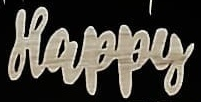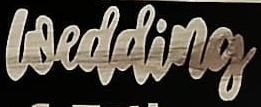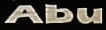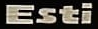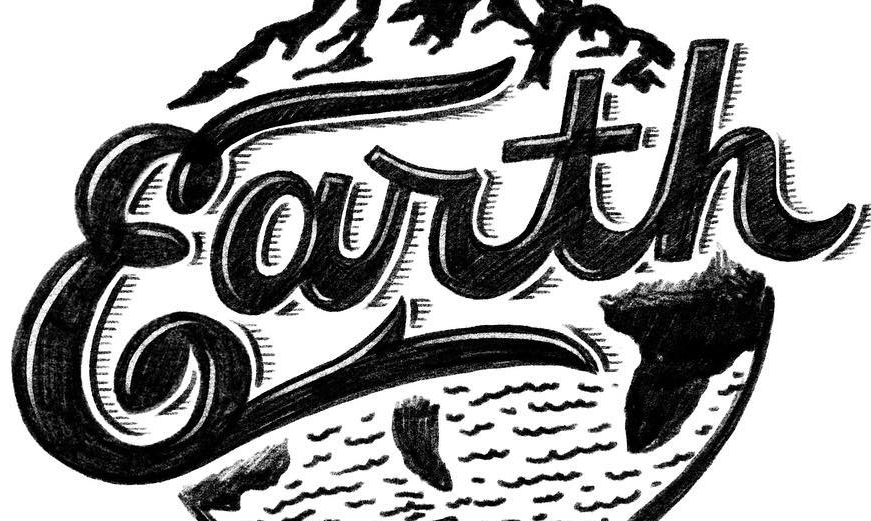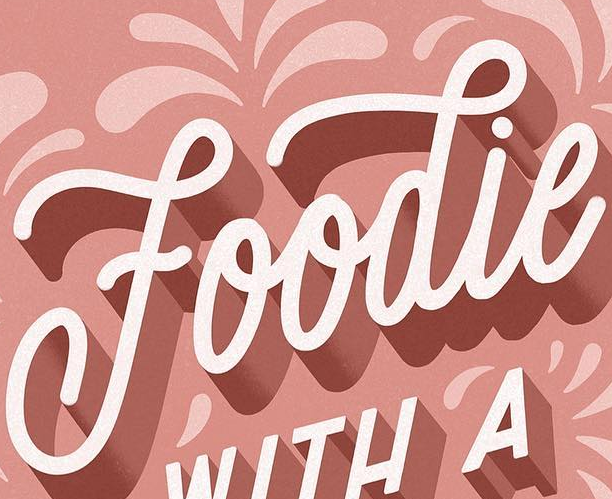Identify the words shown in these images in order, separated by a semicolon. Happy; wedding; Abu; Esti; Earth; Foodie 